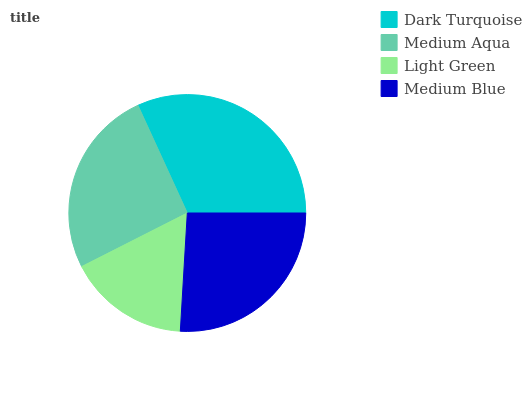Is Light Green the minimum?
Answer yes or no. Yes. Is Dark Turquoise the maximum?
Answer yes or no. Yes. Is Medium Aqua the minimum?
Answer yes or no. No. Is Medium Aqua the maximum?
Answer yes or no. No. Is Dark Turquoise greater than Medium Aqua?
Answer yes or no. Yes. Is Medium Aqua less than Dark Turquoise?
Answer yes or no. Yes. Is Medium Aqua greater than Dark Turquoise?
Answer yes or no. No. Is Dark Turquoise less than Medium Aqua?
Answer yes or no. No. Is Medium Blue the high median?
Answer yes or no. Yes. Is Medium Aqua the low median?
Answer yes or no. Yes. Is Dark Turquoise the high median?
Answer yes or no. No. Is Light Green the low median?
Answer yes or no. No. 